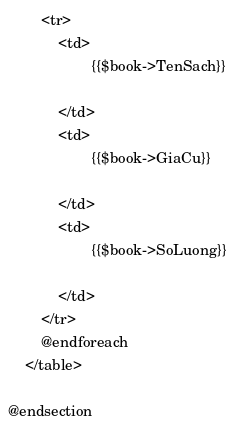<code> <loc_0><loc_0><loc_500><loc_500><_PHP_>        <tr>
            <td>
                    {{$book->TenSach}}

            </td>
            <td>
                    {{$book->GiaCu}}
                    
            </td>
            <td>
                    {{$book->SoLuong}}
                    
            </td>
        </tr>
        @endforeach
    </table>
    
@endsection</code> 